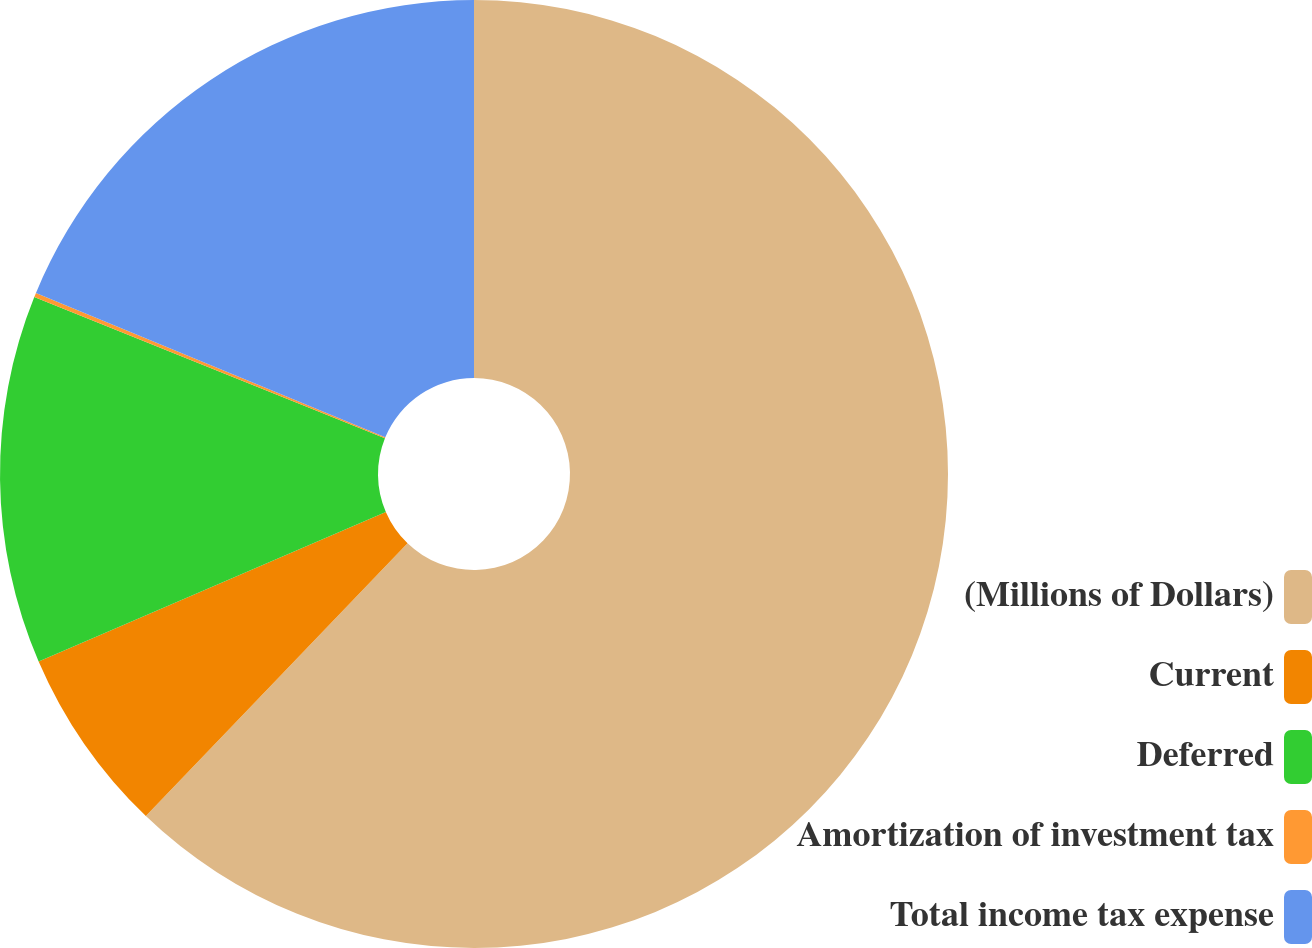<chart> <loc_0><loc_0><loc_500><loc_500><pie_chart><fcel>(Millions of Dollars)<fcel>Current<fcel>Deferred<fcel>Amortization of investment tax<fcel>Total income tax expense<nl><fcel>62.17%<fcel>6.36%<fcel>12.56%<fcel>0.15%<fcel>18.76%<nl></chart> 